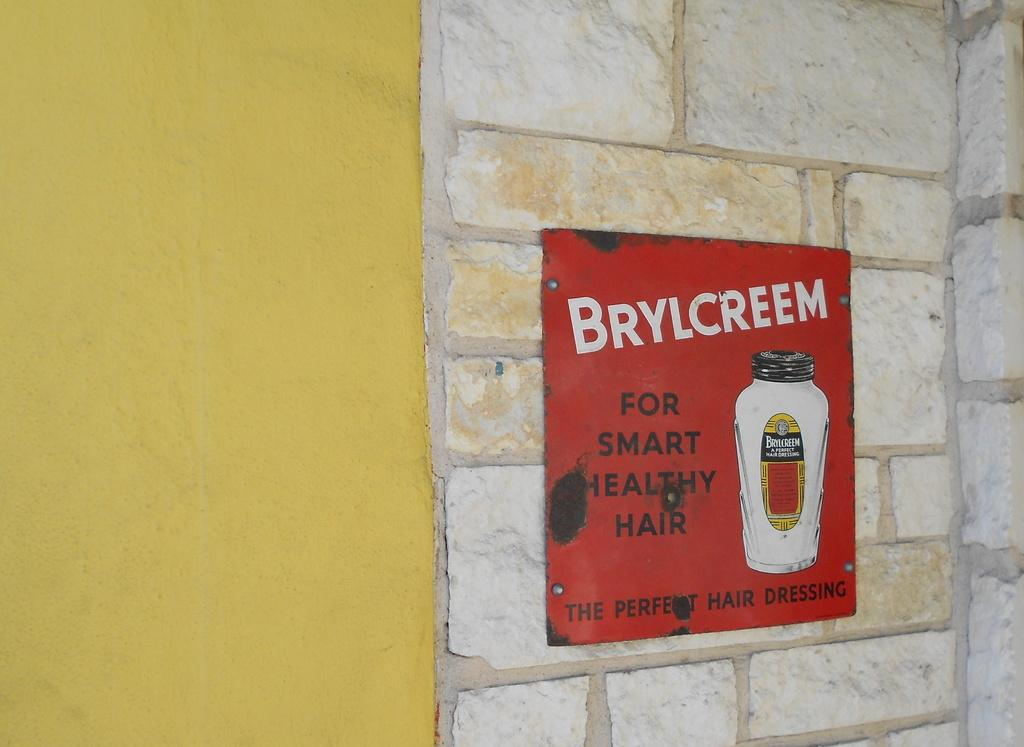<image>
Write a terse but informative summary of the picture. An ad for Brylcreem sits against a brick wall 